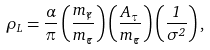<formula> <loc_0><loc_0><loc_500><loc_500>\rho _ { L } = \frac { \alpha } { \pi } \left ( \frac { m _ { \widetilde { \gamma } } } { m _ { \widetilde { \tau } } } \right ) \left ( \frac { { A } _ { \tau } } { m _ { \widetilde { \tau } } } \right ) \left ( \frac { 1 } { \sigma ^ { 2 } } \right ) ,</formula> 